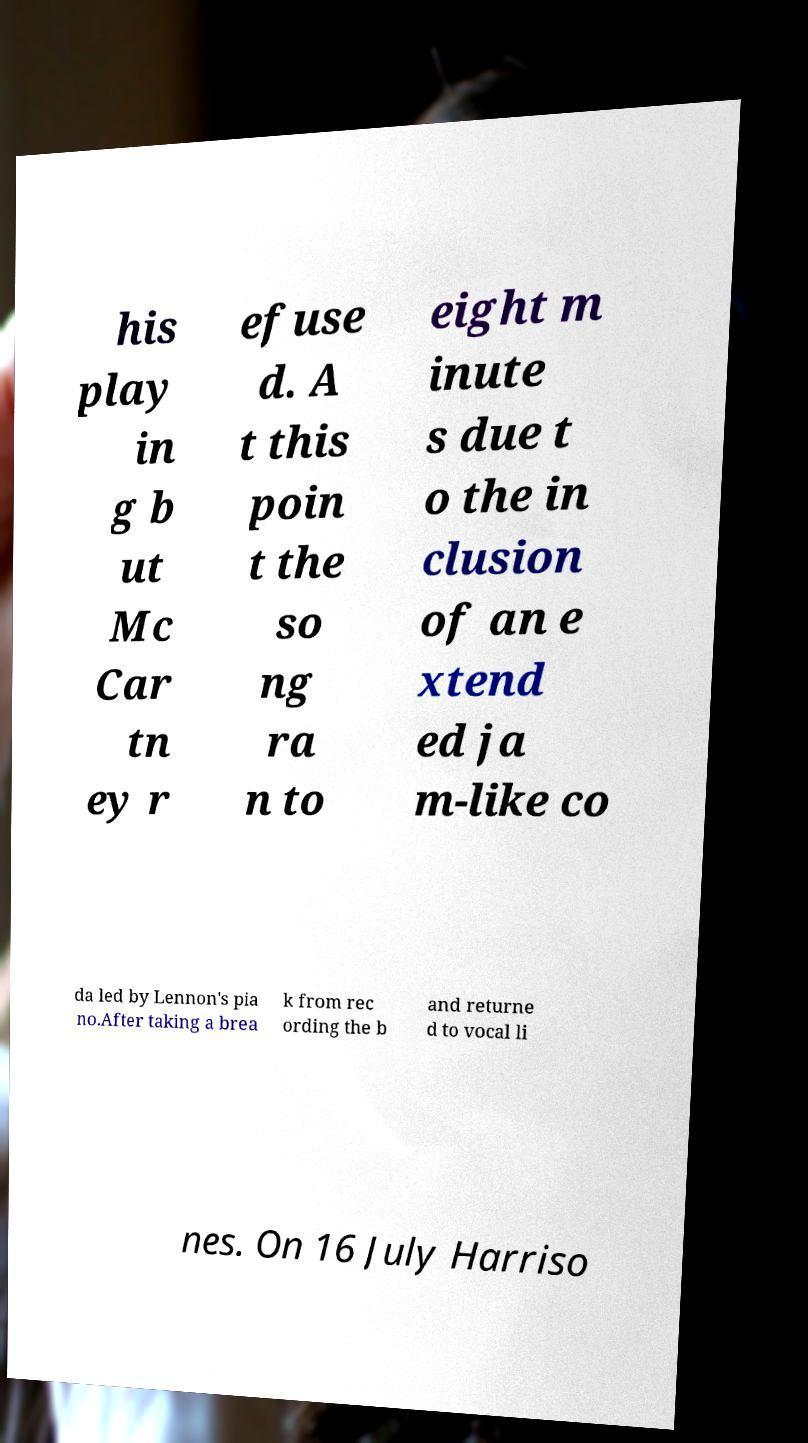Please identify and transcribe the text found in this image. his play in g b ut Mc Car tn ey r efuse d. A t this poin t the so ng ra n to eight m inute s due t o the in clusion of an e xtend ed ja m-like co da led by Lennon's pia no.After taking a brea k from rec ording the b and returne d to vocal li nes. On 16 July Harriso 